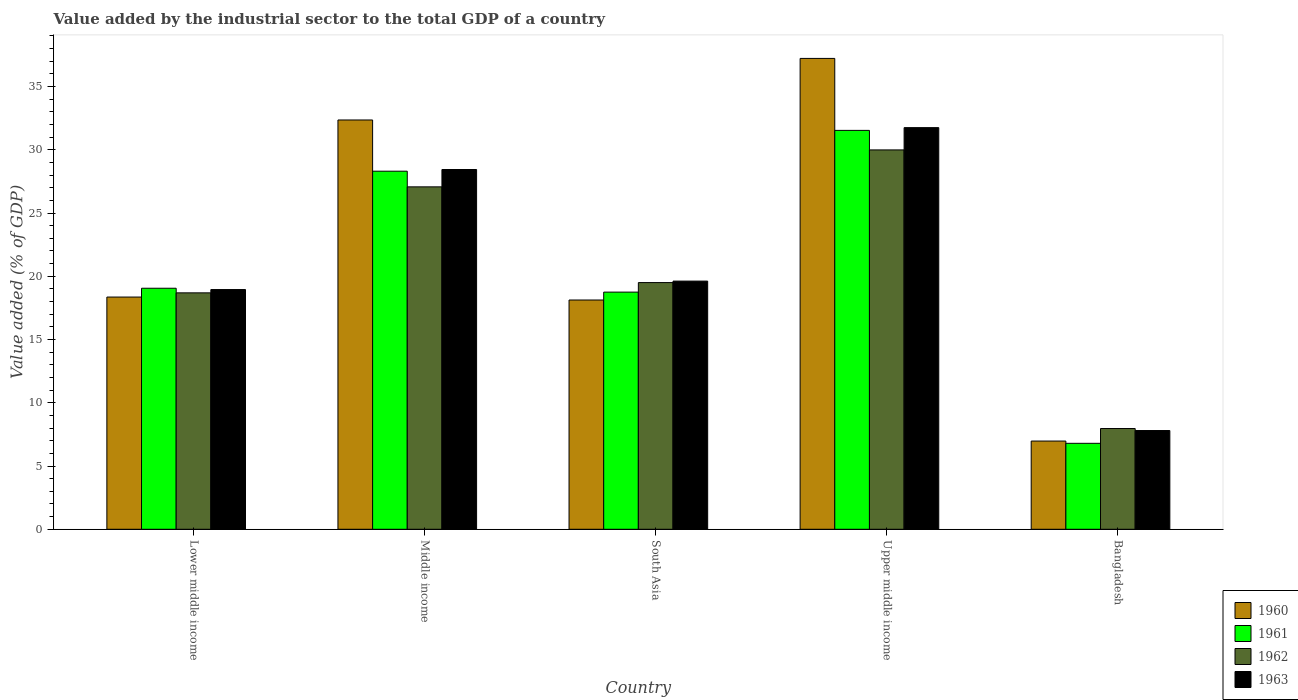How many different coloured bars are there?
Offer a terse response. 4. Are the number of bars per tick equal to the number of legend labels?
Your response must be concise. Yes. Are the number of bars on each tick of the X-axis equal?
Your answer should be very brief. Yes. How many bars are there on the 2nd tick from the left?
Give a very brief answer. 4. How many bars are there on the 4th tick from the right?
Offer a terse response. 4. What is the label of the 1st group of bars from the left?
Ensure brevity in your answer.  Lower middle income. What is the value added by the industrial sector to the total GDP in 1962 in Middle income?
Keep it short and to the point. 27.07. Across all countries, what is the maximum value added by the industrial sector to the total GDP in 1963?
Offer a terse response. 31.75. Across all countries, what is the minimum value added by the industrial sector to the total GDP in 1960?
Offer a very short reply. 6.97. In which country was the value added by the industrial sector to the total GDP in 1961 maximum?
Offer a terse response. Upper middle income. What is the total value added by the industrial sector to the total GDP in 1961 in the graph?
Keep it short and to the point. 104.43. What is the difference between the value added by the industrial sector to the total GDP in 1961 in Bangladesh and that in Upper middle income?
Provide a short and direct response. -24.74. What is the difference between the value added by the industrial sector to the total GDP in 1963 in Lower middle income and the value added by the industrial sector to the total GDP in 1962 in Bangladesh?
Your response must be concise. 10.99. What is the average value added by the industrial sector to the total GDP in 1963 per country?
Offer a terse response. 21.31. What is the difference between the value added by the industrial sector to the total GDP of/in 1961 and value added by the industrial sector to the total GDP of/in 1963 in Lower middle income?
Provide a short and direct response. 0.1. In how many countries, is the value added by the industrial sector to the total GDP in 1960 greater than 14 %?
Provide a succinct answer. 4. What is the ratio of the value added by the industrial sector to the total GDP in 1960 in Lower middle income to that in South Asia?
Provide a succinct answer. 1.01. Is the value added by the industrial sector to the total GDP in 1961 in Bangladesh less than that in South Asia?
Keep it short and to the point. Yes. Is the difference between the value added by the industrial sector to the total GDP in 1961 in Middle income and Upper middle income greater than the difference between the value added by the industrial sector to the total GDP in 1963 in Middle income and Upper middle income?
Provide a short and direct response. Yes. What is the difference between the highest and the second highest value added by the industrial sector to the total GDP in 1963?
Provide a short and direct response. -8.82. What is the difference between the highest and the lowest value added by the industrial sector to the total GDP in 1961?
Provide a short and direct response. 24.74. Is the sum of the value added by the industrial sector to the total GDP in 1962 in Bangladesh and Lower middle income greater than the maximum value added by the industrial sector to the total GDP in 1960 across all countries?
Provide a short and direct response. No. How many countries are there in the graph?
Your answer should be compact. 5. Are the values on the major ticks of Y-axis written in scientific E-notation?
Make the answer very short. No. Does the graph contain grids?
Offer a terse response. No. Where does the legend appear in the graph?
Provide a short and direct response. Bottom right. How many legend labels are there?
Provide a succinct answer. 4. What is the title of the graph?
Keep it short and to the point. Value added by the industrial sector to the total GDP of a country. Does "1990" appear as one of the legend labels in the graph?
Give a very brief answer. No. What is the label or title of the Y-axis?
Provide a short and direct response. Value added (% of GDP). What is the Value added (% of GDP) in 1960 in Lower middle income?
Offer a very short reply. 18.36. What is the Value added (% of GDP) in 1961 in Lower middle income?
Keep it short and to the point. 19.05. What is the Value added (% of GDP) of 1962 in Lower middle income?
Your answer should be very brief. 18.69. What is the Value added (% of GDP) of 1963 in Lower middle income?
Offer a very short reply. 18.95. What is the Value added (% of GDP) of 1960 in Middle income?
Give a very brief answer. 32.35. What is the Value added (% of GDP) of 1961 in Middle income?
Offer a terse response. 28.31. What is the Value added (% of GDP) of 1962 in Middle income?
Give a very brief answer. 27.07. What is the Value added (% of GDP) in 1963 in Middle income?
Your answer should be compact. 28.44. What is the Value added (% of GDP) in 1960 in South Asia?
Make the answer very short. 18.12. What is the Value added (% of GDP) of 1961 in South Asia?
Keep it short and to the point. 18.75. What is the Value added (% of GDP) of 1962 in South Asia?
Ensure brevity in your answer.  19.5. What is the Value added (% of GDP) of 1963 in South Asia?
Provide a succinct answer. 19.62. What is the Value added (% of GDP) of 1960 in Upper middle income?
Offer a very short reply. 37.22. What is the Value added (% of GDP) in 1961 in Upper middle income?
Make the answer very short. 31.53. What is the Value added (% of GDP) in 1962 in Upper middle income?
Keep it short and to the point. 29.99. What is the Value added (% of GDP) of 1963 in Upper middle income?
Your answer should be very brief. 31.75. What is the Value added (% of GDP) in 1960 in Bangladesh?
Make the answer very short. 6.97. What is the Value added (% of GDP) in 1961 in Bangladesh?
Give a very brief answer. 6.79. What is the Value added (% of GDP) of 1962 in Bangladesh?
Your answer should be very brief. 7.96. What is the Value added (% of GDP) in 1963 in Bangladesh?
Give a very brief answer. 7.8. Across all countries, what is the maximum Value added (% of GDP) of 1960?
Your answer should be compact. 37.22. Across all countries, what is the maximum Value added (% of GDP) in 1961?
Your answer should be very brief. 31.53. Across all countries, what is the maximum Value added (% of GDP) of 1962?
Offer a terse response. 29.99. Across all countries, what is the maximum Value added (% of GDP) of 1963?
Your answer should be very brief. 31.75. Across all countries, what is the minimum Value added (% of GDP) of 1960?
Keep it short and to the point. 6.97. Across all countries, what is the minimum Value added (% of GDP) of 1961?
Your response must be concise. 6.79. Across all countries, what is the minimum Value added (% of GDP) of 1962?
Offer a terse response. 7.96. Across all countries, what is the minimum Value added (% of GDP) of 1963?
Your response must be concise. 7.8. What is the total Value added (% of GDP) in 1960 in the graph?
Ensure brevity in your answer.  113.03. What is the total Value added (% of GDP) in 1961 in the graph?
Make the answer very short. 104.43. What is the total Value added (% of GDP) in 1962 in the graph?
Offer a very short reply. 103.21. What is the total Value added (% of GDP) in 1963 in the graph?
Your answer should be very brief. 106.56. What is the difference between the Value added (% of GDP) in 1960 in Lower middle income and that in Middle income?
Ensure brevity in your answer.  -14. What is the difference between the Value added (% of GDP) in 1961 in Lower middle income and that in Middle income?
Ensure brevity in your answer.  -9.25. What is the difference between the Value added (% of GDP) of 1962 in Lower middle income and that in Middle income?
Your answer should be very brief. -8.38. What is the difference between the Value added (% of GDP) in 1963 in Lower middle income and that in Middle income?
Your answer should be compact. -9.49. What is the difference between the Value added (% of GDP) in 1960 in Lower middle income and that in South Asia?
Ensure brevity in your answer.  0.23. What is the difference between the Value added (% of GDP) of 1961 in Lower middle income and that in South Asia?
Make the answer very short. 0.31. What is the difference between the Value added (% of GDP) in 1962 in Lower middle income and that in South Asia?
Provide a succinct answer. -0.81. What is the difference between the Value added (% of GDP) in 1963 in Lower middle income and that in South Asia?
Provide a short and direct response. -0.67. What is the difference between the Value added (% of GDP) of 1960 in Lower middle income and that in Upper middle income?
Keep it short and to the point. -18.86. What is the difference between the Value added (% of GDP) of 1961 in Lower middle income and that in Upper middle income?
Keep it short and to the point. -12.48. What is the difference between the Value added (% of GDP) in 1962 in Lower middle income and that in Upper middle income?
Provide a succinct answer. -11.3. What is the difference between the Value added (% of GDP) in 1963 in Lower middle income and that in Upper middle income?
Your response must be concise. -12.8. What is the difference between the Value added (% of GDP) in 1960 in Lower middle income and that in Bangladesh?
Keep it short and to the point. 11.38. What is the difference between the Value added (% of GDP) of 1961 in Lower middle income and that in Bangladesh?
Offer a very short reply. 12.26. What is the difference between the Value added (% of GDP) in 1962 in Lower middle income and that in Bangladesh?
Give a very brief answer. 10.73. What is the difference between the Value added (% of GDP) of 1963 in Lower middle income and that in Bangladesh?
Your answer should be compact. 11.14. What is the difference between the Value added (% of GDP) in 1960 in Middle income and that in South Asia?
Give a very brief answer. 14.23. What is the difference between the Value added (% of GDP) of 1961 in Middle income and that in South Asia?
Ensure brevity in your answer.  9.56. What is the difference between the Value added (% of GDP) in 1962 in Middle income and that in South Asia?
Provide a short and direct response. 7.57. What is the difference between the Value added (% of GDP) of 1963 in Middle income and that in South Asia?
Give a very brief answer. 8.82. What is the difference between the Value added (% of GDP) of 1960 in Middle income and that in Upper middle income?
Offer a very short reply. -4.87. What is the difference between the Value added (% of GDP) of 1961 in Middle income and that in Upper middle income?
Your answer should be compact. -3.23. What is the difference between the Value added (% of GDP) of 1962 in Middle income and that in Upper middle income?
Offer a very short reply. -2.92. What is the difference between the Value added (% of GDP) of 1963 in Middle income and that in Upper middle income?
Keep it short and to the point. -3.31. What is the difference between the Value added (% of GDP) in 1960 in Middle income and that in Bangladesh?
Your response must be concise. 25.38. What is the difference between the Value added (% of GDP) in 1961 in Middle income and that in Bangladesh?
Your response must be concise. 21.51. What is the difference between the Value added (% of GDP) in 1962 in Middle income and that in Bangladesh?
Make the answer very short. 19.1. What is the difference between the Value added (% of GDP) in 1963 in Middle income and that in Bangladesh?
Provide a short and direct response. 20.63. What is the difference between the Value added (% of GDP) of 1960 in South Asia and that in Upper middle income?
Your response must be concise. -19.1. What is the difference between the Value added (% of GDP) in 1961 in South Asia and that in Upper middle income?
Ensure brevity in your answer.  -12.78. What is the difference between the Value added (% of GDP) in 1962 in South Asia and that in Upper middle income?
Make the answer very short. -10.49. What is the difference between the Value added (% of GDP) in 1963 in South Asia and that in Upper middle income?
Make the answer very short. -12.13. What is the difference between the Value added (% of GDP) in 1960 in South Asia and that in Bangladesh?
Provide a short and direct response. 11.15. What is the difference between the Value added (% of GDP) of 1961 in South Asia and that in Bangladesh?
Provide a succinct answer. 11.95. What is the difference between the Value added (% of GDP) in 1962 in South Asia and that in Bangladesh?
Provide a short and direct response. 11.54. What is the difference between the Value added (% of GDP) in 1963 in South Asia and that in Bangladesh?
Give a very brief answer. 11.81. What is the difference between the Value added (% of GDP) in 1960 in Upper middle income and that in Bangladesh?
Your answer should be compact. 30.25. What is the difference between the Value added (% of GDP) of 1961 in Upper middle income and that in Bangladesh?
Keep it short and to the point. 24.74. What is the difference between the Value added (% of GDP) of 1962 in Upper middle income and that in Bangladesh?
Ensure brevity in your answer.  22.02. What is the difference between the Value added (% of GDP) of 1963 in Upper middle income and that in Bangladesh?
Provide a short and direct response. 23.94. What is the difference between the Value added (% of GDP) of 1960 in Lower middle income and the Value added (% of GDP) of 1961 in Middle income?
Provide a short and direct response. -9.95. What is the difference between the Value added (% of GDP) in 1960 in Lower middle income and the Value added (% of GDP) in 1962 in Middle income?
Keep it short and to the point. -8.71. What is the difference between the Value added (% of GDP) of 1960 in Lower middle income and the Value added (% of GDP) of 1963 in Middle income?
Ensure brevity in your answer.  -10.08. What is the difference between the Value added (% of GDP) of 1961 in Lower middle income and the Value added (% of GDP) of 1962 in Middle income?
Keep it short and to the point. -8.01. What is the difference between the Value added (% of GDP) of 1961 in Lower middle income and the Value added (% of GDP) of 1963 in Middle income?
Ensure brevity in your answer.  -9.39. What is the difference between the Value added (% of GDP) in 1962 in Lower middle income and the Value added (% of GDP) in 1963 in Middle income?
Give a very brief answer. -9.75. What is the difference between the Value added (% of GDP) in 1960 in Lower middle income and the Value added (% of GDP) in 1961 in South Asia?
Provide a succinct answer. -0.39. What is the difference between the Value added (% of GDP) of 1960 in Lower middle income and the Value added (% of GDP) of 1962 in South Asia?
Your response must be concise. -1.14. What is the difference between the Value added (% of GDP) of 1960 in Lower middle income and the Value added (% of GDP) of 1963 in South Asia?
Provide a succinct answer. -1.26. What is the difference between the Value added (% of GDP) in 1961 in Lower middle income and the Value added (% of GDP) in 1962 in South Asia?
Provide a succinct answer. -0.45. What is the difference between the Value added (% of GDP) in 1961 in Lower middle income and the Value added (% of GDP) in 1963 in South Asia?
Your response must be concise. -0.56. What is the difference between the Value added (% of GDP) in 1962 in Lower middle income and the Value added (% of GDP) in 1963 in South Asia?
Keep it short and to the point. -0.93. What is the difference between the Value added (% of GDP) in 1960 in Lower middle income and the Value added (% of GDP) in 1961 in Upper middle income?
Your answer should be compact. -13.17. What is the difference between the Value added (% of GDP) of 1960 in Lower middle income and the Value added (% of GDP) of 1962 in Upper middle income?
Give a very brief answer. -11.63. What is the difference between the Value added (% of GDP) in 1960 in Lower middle income and the Value added (% of GDP) in 1963 in Upper middle income?
Offer a very short reply. -13.39. What is the difference between the Value added (% of GDP) of 1961 in Lower middle income and the Value added (% of GDP) of 1962 in Upper middle income?
Give a very brief answer. -10.93. What is the difference between the Value added (% of GDP) in 1961 in Lower middle income and the Value added (% of GDP) in 1963 in Upper middle income?
Make the answer very short. -12.7. What is the difference between the Value added (% of GDP) of 1962 in Lower middle income and the Value added (% of GDP) of 1963 in Upper middle income?
Offer a terse response. -13.06. What is the difference between the Value added (% of GDP) in 1960 in Lower middle income and the Value added (% of GDP) in 1961 in Bangladesh?
Offer a terse response. 11.56. What is the difference between the Value added (% of GDP) in 1960 in Lower middle income and the Value added (% of GDP) in 1962 in Bangladesh?
Your answer should be compact. 10.39. What is the difference between the Value added (% of GDP) in 1960 in Lower middle income and the Value added (% of GDP) in 1963 in Bangladesh?
Your response must be concise. 10.55. What is the difference between the Value added (% of GDP) in 1961 in Lower middle income and the Value added (% of GDP) in 1962 in Bangladesh?
Ensure brevity in your answer.  11.09. What is the difference between the Value added (% of GDP) of 1961 in Lower middle income and the Value added (% of GDP) of 1963 in Bangladesh?
Make the answer very short. 11.25. What is the difference between the Value added (% of GDP) in 1962 in Lower middle income and the Value added (% of GDP) in 1963 in Bangladesh?
Make the answer very short. 10.88. What is the difference between the Value added (% of GDP) in 1960 in Middle income and the Value added (% of GDP) in 1961 in South Asia?
Make the answer very short. 13.61. What is the difference between the Value added (% of GDP) in 1960 in Middle income and the Value added (% of GDP) in 1962 in South Asia?
Give a very brief answer. 12.85. What is the difference between the Value added (% of GDP) of 1960 in Middle income and the Value added (% of GDP) of 1963 in South Asia?
Ensure brevity in your answer.  12.74. What is the difference between the Value added (% of GDP) of 1961 in Middle income and the Value added (% of GDP) of 1962 in South Asia?
Make the answer very short. 8.8. What is the difference between the Value added (% of GDP) of 1961 in Middle income and the Value added (% of GDP) of 1963 in South Asia?
Offer a terse response. 8.69. What is the difference between the Value added (% of GDP) in 1962 in Middle income and the Value added (% of GDP) in 1963 in South Asia?
Keep it short and to the point. 7.45. What is the difference between the Value added (% of GDP) of 1960 in Middle income and the Value added (% of GDP) of 1961 in Upper middle income?
Provide a short and direct response. 0.82. What is the difference between the Value added (% of GDP) in 1960 in Middle income and the Value added (% of GDP) in 1962 in Upper middle income?
Provide a succinct answer. 2.37. What is the difference between the Value added (% of GDP) of 1960 in Middle income and the Value added (% of GDP) of 1963 in Upper middle income?
Give a very brief answer. 0.61. What is the difference between the Value added (% of GDP) of 1961 in Middle income and the Value added (% of GDP) of 1962 in Upper middle income?
Provide a succinct answer. -1.68. What is the difference between the Value added (% of GDP) in 1961 in Middle income and the Value added (% of GDP) in 1963 in Upper middle income?
Make the answer very short. -3.44. What is the difference between the Value added (% of GDP) in 1962 in Middle income and the Value added (% of GDP) in 1963 in Upper middle income?
Provide a succinct answer. -4.68. What is the difference between the Value added (% of GDP) of 1960 in Middle income and the Value added (% of GDP) of 1961 in Bangladesh?
Make the answer very short. 25.56. What is the difference between the Value added (% of GDP) in 1960 in Middle income and the Value added (% of GDP) in 1962 in Bangladesh?
Give a very brief answer. 24.39. What is the difference between the Value added (% of GDP) in 1960 in Middle income and the Value added (% of GDP) in 1963 in Bangladesh?
Make the answer very short. 24.55. What is the difference between the Value added (% of GDP) of 1961 in Middle income and the Value added (% of GDP) of 1962 in Bangladesh?
Offer a terse response. 20.34. What is the difference between the Value added (% of GDP) in 1961 in Middle income and the Value added (% of GDP) in 1963 in Bangladesh?
Offer a very short reply. 20.5. What is the difference between the Value added (% of GDP) in 1962 in Middle income and the Value added (% of GDP) in 1963 in Bangladesh?
Your response must be concise. 19.26. What is the difference between the Value added (% of GDP) of 1960 in South Asia and the Value added (% of GDP) of 1961 in Upper middle income?
Your answer should be compact. -13.41. What is the difference between the Value added (% of GDP) in 1960 in South Asia and the Value added (% of GDP) in 1962 in Upper middle income?
Provide a short and direct response. -11.86. What is the difference between the Value added (% of GDP) of 1960 in South Asia and the Value added (% of GDP) of 1963 in Upper middle income?
Make the answer very short. -13.63. What is the difference between the Value added (% of GDP) of 1961 in South Asia and the Value added (% of GDP) of 1962 in Upper middle income?
Your answer should be very brief. -11.24. What is the difference between the Value added (% of GDP) in 1961 in South Asia and the Value added (% of GDP) in 1963 in Upper middle income?
Ensure brevity in your answer.  -13. What is the difference between the Value added (% of GDP) in 1962 in South Asia and the Value added (% of GDP) in 1963 in Upper middle income?
Ensure brevity in your answer.  -12.25. What is the difference between the Value added (% of GDP) of 1960 in South Asia and the Value added (% of GDP) of 1961 in Bangladesh?
Offer a terse response. 11.33. What is the difference between the Value added (% of GDP) of 1960 in South Asia and the Value added (% of GDP) of 1962 in Bangladesh?
Provide a short and direct response. 10.16. What is the difference between the Value added (% of GDP) of 1960 in South Asia and the Value added (% of GDP) of 1963 in Bangladesh?
Make the answer very short. 10.32. What is the difference between the Value added (% of GDP) of 1961 in South Asia and the Value added (% of GDP) of 1962 in Bangladesh?
Make the answer very short. 10.78. What is the difference between the Value added (% of GDP) of 1961 in South Asia and the Value added (% of GDP) of 1963 in Bangladesh?
Your response must be concise. 10.94. What is the difference between the Value added (% of GDP) in 1962 in South Asia and the Value added (% of GDP) in 1963 in Bangladesh?
Provide a short and direct response. 11.7. What is the difference between the Value added (% of GDP) in 1960 in Upper middle income and the Value added (% of GDP) in 1961 in Bangladesh?
Provide a short and direct response. 30.43. What is the difference between the Value added (% of GDP) in 1960 in Upper middle income and the Value added (% of GDP) in 1962 in Bangladesh?
Provide a short and direct response. 29.26. What is the difference between the Value added (% of GDP) in 1960 in Upper middle income and the Value added (% of GDP) in 1963 in Bangladesh?
Ensure brevity in your answer.  29.42. What is the difference between the Value added (% of GDP) of 1961 in Upper middle income and the Value added (% of GDP) of 1962 in Bangladesh?
Keep it short and to the point. 23.57. What is the difference between the Value added (% of GDP) of 1961 in Upper middle income and the Value added (% of GDP) of 1963 in Bangladesh?
Your answer should be compact. 23.73. What is the difference between the Value added (% of GDP) of 1962 in Upper middle income and the Value added (% of GDP) of 1963 in Bangladesh?
Your answer should be compact. 22.18. What is the average Value added (% of GDP) of 1960 per country?
Provide a short and direct response. 22.61. What is the average Value added (% of GDP) of 1961 per country?
Offer a very short reply. 20.89. What is the average Value added (% of GDP) in 1962 per country?
Your answer should be compact. 20.64. What is the average Value added (% of GDP) in 1963 per country?
Provide a succinct answer. 21.31. What is the difference between the Value added (% of GDP) of 1960 and Value added (% of GDP) of 1961 in Lower middle income?
Make the answer very short. -0.7. What is the difference between the Value added (% of GDP) of 1960 and Value added (% of GDP) of 1962 in Lower middle income?
Offer a terse response. -0.33. What is the difference between the Value added (% of GDP) of 1960 and Value added (% of GDP) of 1963 in Lower middle income?
Keep it short and to the point. -0.59. What is the difference between the Value added (% of GDP) in 1961 and Value added (% of GDP) in 1962 in Lower middle income?
Provide a succinct answer. 0.36. What is the difference between the Value added (% of GDP) in 1961 and Value added (% of GDP) in 1963 in Lower middle income?
Provide a short and direct response. 0.1. What is the difference between the Value added (% of GDP) in 1962 and Value added (% of GDP) in 1963 in Lower middle income?
Make the answer very short. -0.26. What is the difference between the Value added (% of GDP) in 1960 and Value added (% of GDP) in 1961 in Middle income?
Your answer should be very brief. 4.05. What is the difference between the Value added (% of GDP) in 1960 and Value added (% of GDP) in 1962 in Middle income?
Keep it short and to the point. 5.29. What is the difference between the Value added (% of GDP) in 1960 and Value added (% of GDP) in 1963 in Middle income?
Keep it short and to the point. 3.92. What is the difference between the Value added (% of GDP) of 1961 and Value added (% of GDP) of 1962 in Middle income?
Offer a very short reply. 1.24. What is the difference between the Value added (% of GDP) of 1961 and Value added (% of GDP) of 1963 in Middle income?
Offer a very short reply. -0.13. What is the difference between the Value added (% of GDP) of 1962 and Value added (% of GDP) of 1963 in Middle income?
Provide a succinct answer. -1.37. What is the difference between the Value added (% of GDP) of 1960 and Value added (% of GDP) of 1961 in South Asia?
Give a very brief answer. -0.62. What is the difference between the Value added (% of GDP) in 1960 and Value added (% of GDP) in 1962 in South Asia?
Make the answer very short. -1.38. What is the difference between the Value added (% of GDP) in 1960 and Value added (% of GDP) in 1963 in South Asia?
Offer a terse response. -1.49. What is the difference between the Value added (% of GDP) in 1961 and Value added (% of GDP) in 1962 in South Asia?
Give a very brief answer. -0.75. What is the difference between the Value added (% of GDP) of 1961 and Value added (% of GDP) of 1963 in South Asia?
Ensure brevity in your answer.  -0.87. What is the difference between the Value added (% of GDP) in 1962 and Value added (% of GDP) in 1963 in South Asia?
Keep it short and to the point. -0.12. What is the difference between the Value added (% of GDP) in 1960 and Value added (% of GDP) in 1961 in Upper middle income?
Offer a very short reply. 5.69. What is the difference between the Value added (% of GDP) of 1960 and Value added (% of GDP) of 1962 in Upper middle income?
Make the answer very short. 7.23. What is the difference between the Value added (% of GDP) in 1960 and Value added (% of GDP) in 1963 in Upper middle income?
Give a very brief answer. 5.47. What is the difference between the Value added (% of GDP) in 1961 and Value added (% of GDP) in 1962 in Upper middle income?
Offer a very short reply. 1.54. What is the difference between the Value added (% of GDP) of 1961 and Value added (% of GDP) of 1963 in Upper middle income?
Offer a terse response. -0.22. What is the difference between the Value added (% of GDP) in 1962 and Value added (% of GDP) in 1963 in Upper middle income?
Provide a succinct answer. -1.76. What is the difference between the Value added (% of GDP) in 1960 and Value added (% of GDP) in 1961 in Bangladesh?
Give a very brief answer. 0.18. What is the difference between the Value added (% of GDP) in 1960 and Value added (% of GDP) in 1962 in Bangladesh?
Make the answer very short. -0.99. What is the difference between the Value added (% of GDP) of 1960 and Value added (% of GDP) of 1963 in Bangladesh?
Provide a succinct answer. -0.83. What is the difference between the Value added (% of GDP) of 1961 and Value added (% of GDP) of 1962 in Bangladesh?
Your response must be concise. -1.17. What is the difference between the Value added (% of GDP) in 1961 and Value added (% of GDP) in 1963 in Bangladesh?
Your response must be concise. -1.01. What is the difference between the Value added (% of GDP) of 1962 and Value added (% of GDP) of 1963 in Bangladesh?
Give a very brief answer. 0.16. What is the ratio of the Value added (% of GDP) in 1960 in Lower middle income to that in Middle income?
Offer a very short reply. 0.57. What is the ratio of the Value added (% of GDP) in 1961 in Lower middle income to that in Middle income?
Ensure brevity in your answer.  0.67. What is the ratio of the Value added (% of GDP) in 1962 in Lower middle income to that in Middle income?
Provide a succinct answer. 0.69. What is the ratio of the Value added (% of GDP) in 1963 in Lower middle income to that in Middle income?
Ensure brevity in your answer.  0.67. What is the ratio of the Value added (% of GDP) of 1960 in Lower middle income to that in South Asia?
Ensure brevity in your answer.  1.01. What is the ratio of the Value added (% of GDP) of 1961 in Lower middle income to that in South Asia?
Keep it short and to the point. 1.02. What is the ratio of the Value added (% of GDP) of 1962 in Lower middle income to that in South Asia?
Your answer should be compact. 0.96. What is the ratio of the Value added (% of GDP) of 1963 in Lower middle income to that in South Asia?
Offer a very short reply. 0.97. What is the ratio of the Value added (% of GDP) in 1960 in Lower middle income to that in Upper middle income?
Ensure brevity in your answer.  0.49. What is the ratio of the Value added (% of GDP) of 1961 in Lower middle income to that in Upper middle income?
Keep it short and to the point. 0.6. What is the ratio of the Value added (% of GDP) in 1962 in Lower middle income to that in Upper middle income?
Provide a short and direct response. 0.62. What is the ratio of the Value added (% of GDP) in 1963 in Lower middle income to that in Upper middle income?
Make the answer very short. 0.6. What is the ratio of the Value added (% of GDP) of 1960 in Lower middle income to that in Bangladesh?
Give a very brief answer. 2.63. What is the ratio of the Value added (% of GDP) in 1961 in Lower middle income to that in Bangladesh?
Your response must be concise. 2.8. What is the ratio of the Value added (% of GDP) in 1962 in Lower middle income to that in Bangladesh?
Make the answer very short. 2.35. What is the ratio of the Value added (% of GDP) of 1963 in Lower middle income to that in Bangladesh?
Your answer should be compact. 2.43. What is the ratio of the Value added (% of GDP) in 1960 in Middle income to that in South Asia?
Make the answer very short. 1.79. What is the ratio of the Value added (% of GDP) of 1961 in Middle income to that in South Asia?
Give a very brief answer. 1.51. What is the ratio of the Value added (% of GDP) of 1962 in Middle income to that in South Asia?
Your answer should be very brief. 1.39. What is the ratio of the Value added (% of GDP) in 1963 in Middle income to that in South Asia?
Your response must be concise. 1.45. What is the ratio of the Value added (% of GDP) in 1960 in Middle income to that in Upper middle income?
Offer a very short reply. 0.87. What is the ratio of the Value added (% of GDP) of 1961 in Middle income to that in Upper middle income?
Give a very brief answer. 0.9. What is the ratio of the Value added (% of GDP) of 1962 in Middle income to that in Upper middle income?
Keep it short and to the point. 0.9. What is the ratio of the Value added (% of GDP) in 1963 in Middle income to that in Upper middle income?
Provide a short and direct response. 0.9. What is the ratio of the Value added (% of GDP) in 1960 in Middle income to that in Bangladesh?
Offer a very short reply. 4.64. What is the ratio of the Value added (% of GDP) of 1961 in Middle income to that in Bangladesh?
Give a very brief answer. 4.17. What is the ratio of the Value added (% of GDP) of 1962 in Middle income to that in Bangladesh?
Give a very brief answer. 3.4. What is the ratio of the Value added (% of GDP) of 1963 in Middle income to that in Bangladesh?
Provide a short and direct response. 3.64. What is the ratio of the Value added (% of GDP) of 1960 in South Asia to that in Upper middle income?
Provide a succinct answer. 0.49. What is the ratio of the Value added (% of GDP) of 1961 in South Asia to that in Upper middle income?
Ensure brevity in your answer.  0.59. What is the ratio of the Value added (% of GDP) in 1962 in South Asia to that in Upper middle income?
Provide a short and direct response. 0.65. What is the ratio of the Value added (% of GDP) in 1963 in South Asia to that in Upper middle income?
Make the answer very short. 0.62. What is the ratio of the Value added (% of GDP) of 1960 in South Asia to that in Bangladesh?
Offer a terse response. 2.6. What is the ratio of the Value added (% of GDP) in 1961 in South Asia to that in Bangladesh?
Keep it short and to the point. 2.76. What is the ratio of the Value added (% of GDP) of 1962 in South Asia to that in Bangladesh?
Keep it short and to the point. 2.45. What is the ratio of the Value added (% of GDP) of 1963 in South Asia to that in Bangladesh?
Provide a succinct answer. 2.51. What is the ratio of the Value added (% of GDP) in 1960 in Upper middle income to that in Bangladesh?
Offer a terse response. 5.34. What is the ratio of the Value added (% of GDP) in 1961 in Upper middle income to that in Bangladesh?
Offer a very short reply. 4.64. What is the ratio of the Value added (% of GDP) of 1962 in Upper middle income to that in Bangladesh?
Offer a very short reply. 3.77. What is the ratio of the Value added (% of GDP) of 1963 in Upper middle income to that in Bangladesh?
Make the answer very short. 4.07. What is the difference between the highest and the second highest Value added (% of GDP) of 1960?
Make the answer very short. 4.87. What is the difference between the highest and the second highest Value added (% of GDP) of 1961?
Your answer should be very brief. 3.23. What is the difference between the highest and the second highest Value added (% of GDP) in 1962?
Provide a succinct answer. 2.92. What is the difference between the highest and the second highest Value added (% of GDP) in 1963?
Your answer should be very brief. 3.31. What is the difference between the highest and the lowest Value added (% of GDP) in 1960?
Provide a short and direct response. 30.25. What is the difference between the highest and the lowest Value added (% of GDP) in 1961?
Ensure brevity in your answer.  24.74. What is the difference between the highest and the lowest Value added (% of GDP) of 1962?
Your response must be concise. 22.02. What is the difference between the highest and the lowest Value added (% of GDP) in 1963?
Make the answer very short. 23.94. 